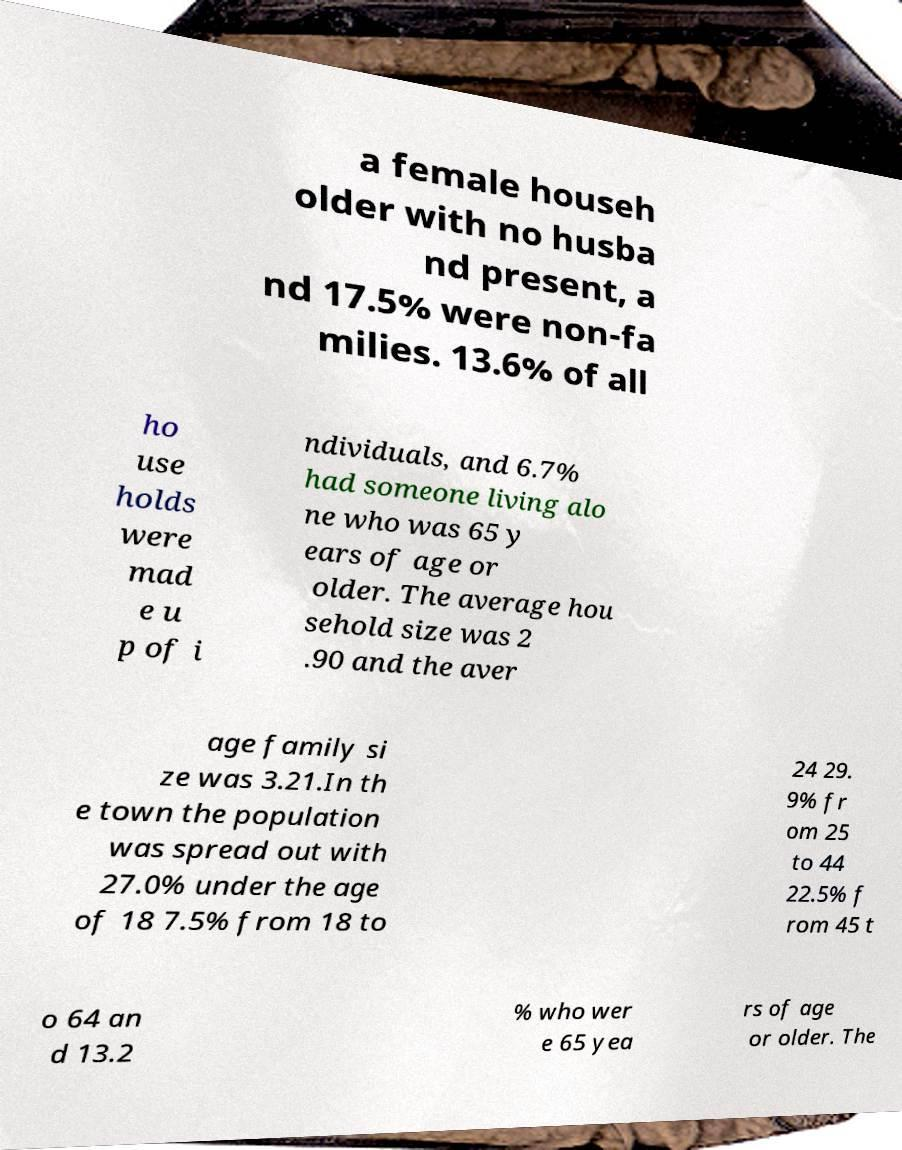For documentation purposes, I need the text within this image transcribed. Could you provide that? a female househ older with no husba nd present, a nd 17.5% were non-fa milies. 13.6% of all ho use holds were mad e u p of i ndividuals, and 6.7% had someone living alo ne who was 65 y ears of age or older. The average hou sehold size was 2 .90 and the aver age family si ze was 3.21.In th e town the population was spread out with 27.0% under the age of 18 7.5% from 18 to 24 29. 9% fr om 25 to 44 22.5% f rom 45 t o 64 an d 13.2 % who wer e 65 yea rs of age or older. The 